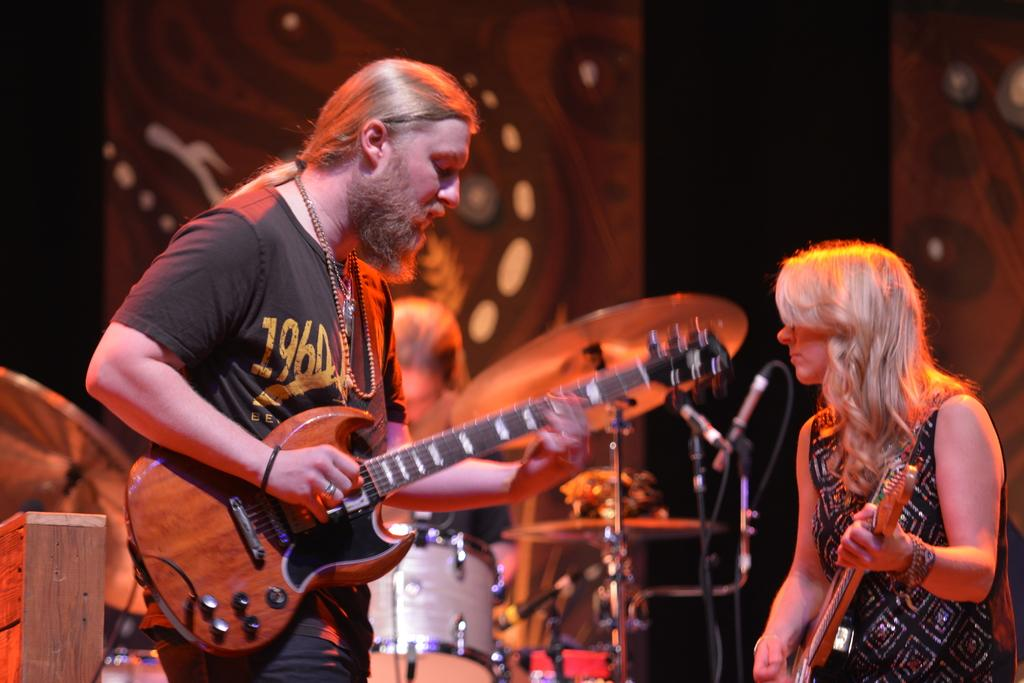What type of people can be seen in the image? There are musicians in the image. What instrument is the man playing? The man is playing a guitar. What instrument is the woman playing? The woman is also playing a guitar. What other musical instrument can be seen in the image? There are drums in the background of the image. How many pets are visible in the image? There are no pets present in the image; it features musicians playing guitars and drums. What type of hat is the actor wearing in the image? There is no actor or hat present in the image; it features musicians playing guitars and drums. 